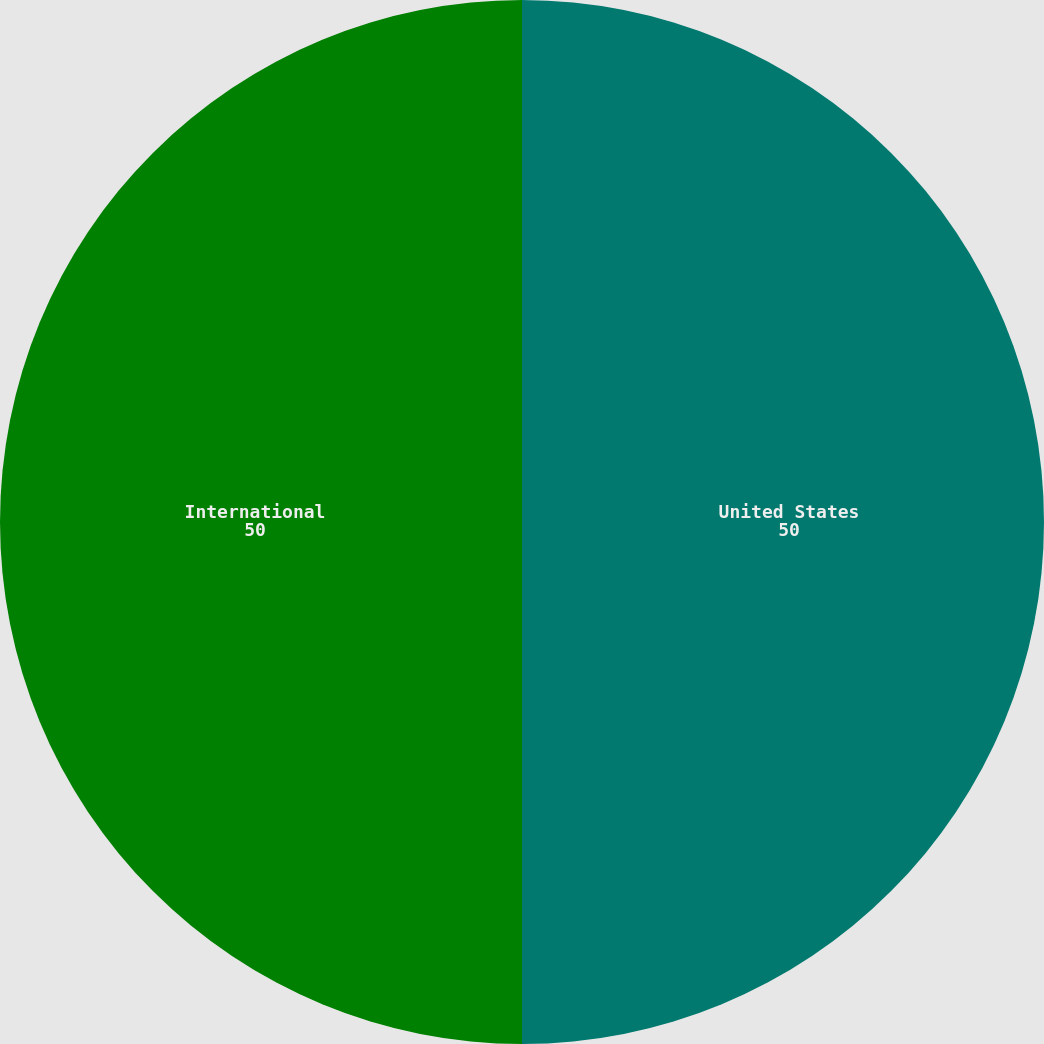Convert chart to OTSL. <chart><loc_0><loc_0><loc_500><loc_500><pie_chart><fcel>United States<fcel>International<nl><fcel>50.0%<fcel>50.0%<nl></chart> 